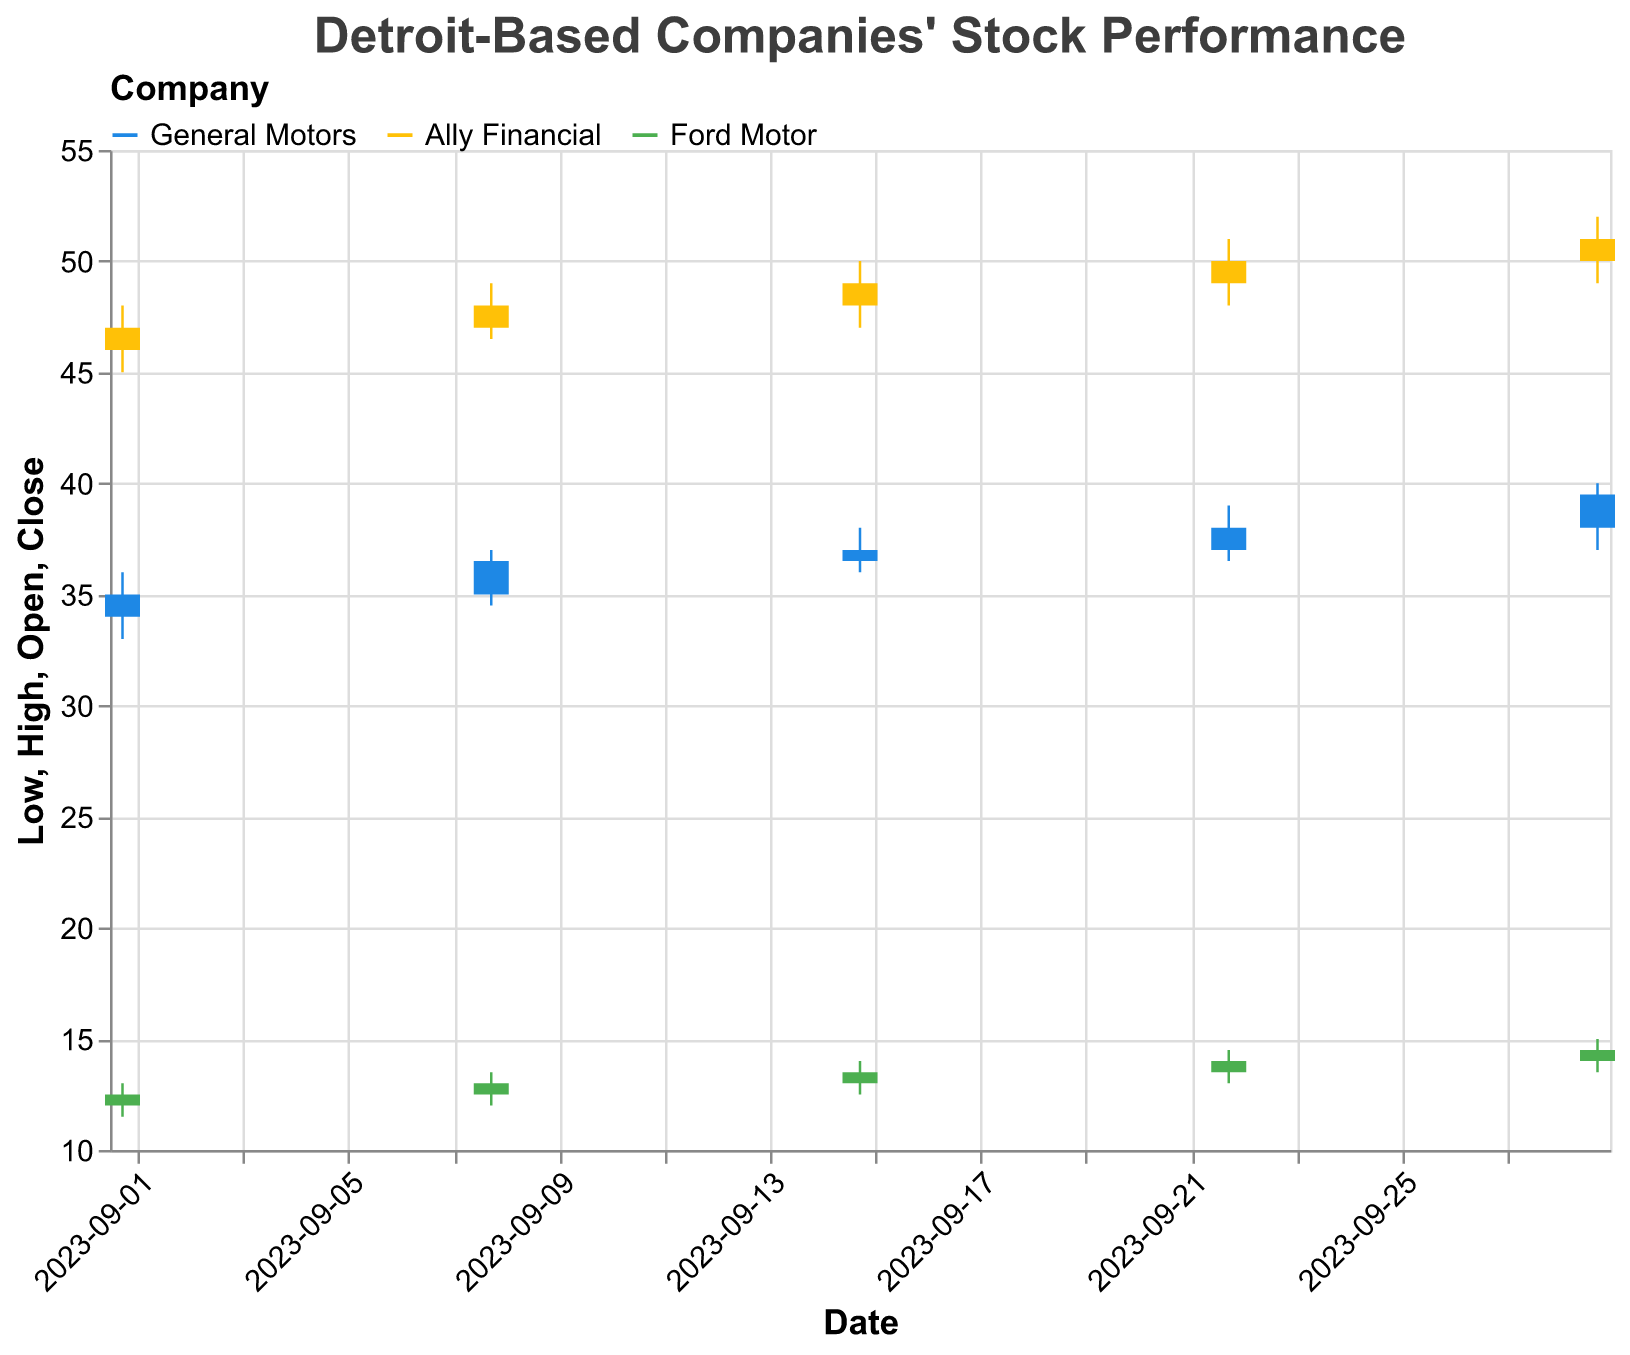What is the title of the figure? The title is located at the top of the figure, and it provides an overview of what the figure is about.
Answer: Detroit-Based Companies' Stock Performance Which company had the highest closing stock price on September 29th? By referring to the data points for September 29th, the highest closing prices for General Motors, Ally Financial, and Ford Motor are analyzed.
Answer: Ally Financial What's the average closing price of Ford Motor over the given period? To find the average closing price, sum up the closing prices of Ford Motor over all dates and then divide by the number of dates: (12.5 + 13 + 13.5 + 14 + 14.5) / 5.
Answer: 13.5 During which week did General Motors have the highest closing stock price, and what was it? Look at the closing prices for General Motors for each date and identify the highest value. The highest closing price for General Motors is 39.5, which occurred on September 29th.
Answer: September 29th, 39.5 Compare the closing prices of Ally Financial and Ford Motor on September 15th. Which company had a higher closing price? The closing prices for Ally Financial and Ford Motor on September 15th are compared. Ally Financial closed at 49 and Ford Motor closed at 13.5.
Answer: Ally Financial Which company experienced the largest increase in closing stock price from September 1st to September 29th? To determine this, the closing prices on September 1st and September 29th for each company need to be compared. The increases are: General Motors (35 to 39.5), Ally Financial (47 to 51), Ford Motor (12.5 to 14.5). General Motors' increase is 4.5, Ally Financial’s increase is 4, Ford Motor’s increase is 2. Therefore, General Motors experienced the largest increase.
Answer: General Motors On which date did Ford Motor have its highest high price, and what was that price? Analyze the high prices for Ford Motor across all dates given in the dataset. The highest high price for Ford Motor was 15, which occurred on September 29th.
Answer: September 29th, 15 Did any company’s closing stock price decrease continuously over three or more consecutive weeks? Evaluate the closing prices of each company week-by-week to identify any continuous decrease. Detroit Lions show a drop from 66 to 24 to 14 and finally to 27 continuously.
Answer: No continuous decrease for GM, Ally Financial, or Ford What was the low price of General Motors on September 22nd? Check the data point for General Motors on September 22nd and identify the low price. The low price for General Motors on this date was 36.5.
Answer: 36.5 